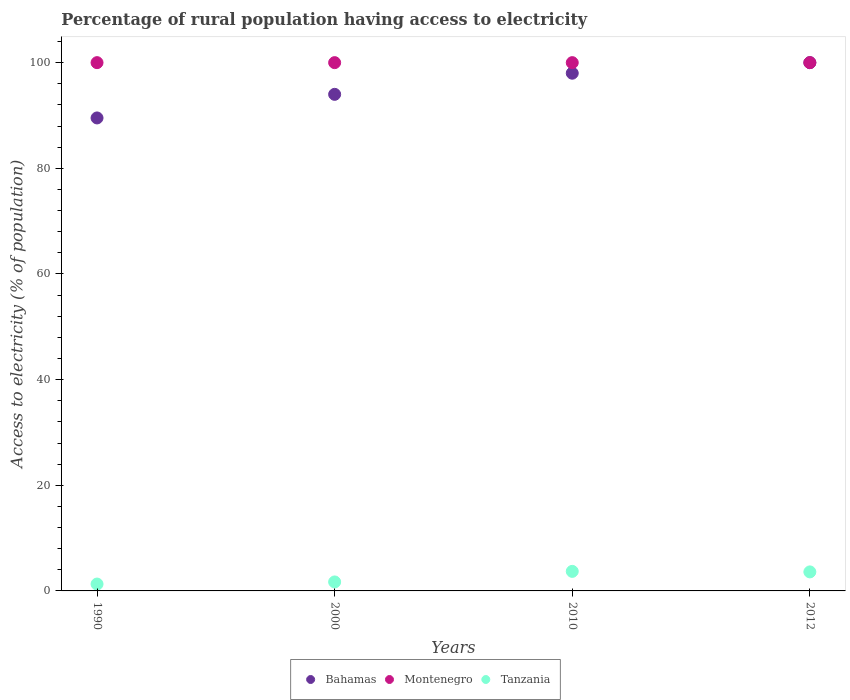How many different coloured dotlines are there?
Provide a short and direct response. 3. What is the percentage of rural population having access to electricity in Bahamas in 2000?
Your answer should be very brief. 94. Across all years, what is the minimum percentage of rural population having access to electricity in Montenegro?
Provide a short and direct response. 100. In which year was the percentage of rural population having access to electricity in Bahamas maximum?
Give a very brief answer. 2012. In which year was the percentage of rural population having access to electricity in Tanzania minimum?
Offer a terse response. 1990. What is the total percentage of rural population having access to electricity in Bahamas in the graph?
Provide a short and direct response. 381.53. What is the difference between the percentage of rural population having access to electricity in Montenegro in 1990 and the percentage of rural population having access to electricity in Tanzania in 2010?
Keep it short and to the point. 96.3. What is the average percentage of rural population having access to electricity in Montenegro per year?
Offer a very short reply. 100. In the year 2012, what is the difference between the percentage of rural population having access to electricity in Tanzania and percentage of rural population having access to electricity in Bahamas?
Your answer should be compact. -96.4. What is the ratio of the percentage of rural population having access to electricity in Montenegro in 1990 to that in 2010?
Make the answer very short. 1. Is the difference between the percentage of rural population having access to electricity in Tanzania in 1990 and 2010 greater than the difference between the percentage of rural population having access to electricity in Bahamas in 1990 and 2010?
Your response must be concise. Yes. What is the difference between the highest and the lowest percentage of rural population having access to electricity in Tanzania?
Provide a short and direct response. 2.4. In how many years, is the percentage of rural population having access to electricity in Bahamas greater than the average percentage of rural population having access to electricity in Bahamas taken over all years?
Keep it short and to the point. 2. Does the percentage of rural population having access to electricity in Montenegro monotonically increase over the years?
Make the answer very short. No. Is the percentage of rural population having access to electricity in Montenegro strictly less than the percentage of rural population having access to electricity in Tanzania over the years?
Offer a very short reply. No. How many dotlines are there?
Your response must be concise. 3. How many years are there in the graph?
Your answer should be very brief. 4. What is the difference between two consecutive major ticks on the Y-axis?
Keep it short and to the point. 20. Are the values on the major ticks of Y-axis written in scientific E-notation?
Your answer should be compact. No. Where does the legend appear in the graph?
Give a very brief answer. Bottom center. What is the title of the graph?
Provide a short and direct response. Percentage of rural population having access to electricity. What is the label or title of the X-axis?
Offer a terse response. Years. What is the label or title of the Y-axis?
Keep it short and to the point. Access to electricity (% of population). What is the Access to electricity (% of population) of Bahamas in 1990?
Offer a terse response. 89.53. What is the Access to electricity (% of population) of Montenegro in 1990?
Offer a terse response. 100. What is the Access to electricity (% of population) in Bahamas in 2000?
Offer a terse response. 94. What is the Access to electricity (% of population) in Montenegro in 2000?
Provide a succinct answer. 100. What is the Access to electricity (% of population) in Bahamas in 2010?
Give a very brief answer. 98. What is the Access to electricity (% of population) in Montenegro in 2010?
Provide a succinct answer. 100. What is the Access to electricity (% of population) in Bahamas in 2012?
Offer a terse response. 100. What is the Access to electricity (% of population) of Montenegro in 2012?
Keep it short and to the point. 100. Across all years, what is the maximum Access to electricity (% of population) of Bahamas?
Your answer should be compact. 100. Across all years, what is the maximum Access to electricity (% of population) in Tanzania?
Ensure brevity in your answer.  3.7. Across all years, what is the minimum Access to electricity (% of population) of Bahamas?
Your answer should be compact. 89.53. Across all years, what is the minimum Access to electricity (% of population) of Tanzania?
Ensure brevity in your answer.  1.3. What is the total Access to electricity (% of population) of Bahamas in the graph?
Keep it short and to the point. 381.53. What is the total Access to electricity (% of population) of Montenegro in the graph?
Make the answer very short. 400. What is the total Access to electricity (% of population) of Tanzania in the graph?
Offer a terse response. 10.3. What is the difference between the Access to electricity (% of population) of Bahamas in 1990 and that in 2000?
Offer a terse response. -4.47. What is the difference between the Access to electricity (% of population) of Montenegro in 1990 and that in 2000?
Your answer should be very brief. 0. What is the difference between the Access to electricity (% of population) in Bahamas in 1990 and that in 2010?
Make the answer very short. -8.47. What is the difference between the Access to electricity (% of population) in Montenegro in 1990 and that in 2010?
Give a very brief answer. 0. What is the difference between the Access to electricity (% of population) of Tanzania in 1990 and that in 2010?
Make the answer very short. -2.4. What is the difference between the Access to electricity (% of population) of Bahamas in 1990 and that in 2012?
Your response must be concise. -10.47. What is the difference between the Access to electricity (% of population) of Tanzania in 1990 and that in 2012?
Make the answer very short. -2.3. What is the difference between the Access to electricity (% of population) of Bahamas in 2000 and that in 2010?
Your answer should be very brief. -4. What is the difference between the Access to electricity (% of population) of Montenegro in 2000 and that in 2010?
Your response must be concise. 0. What is the difference between the Access to electricity (% of population) in Bahamas in 2000 and that in 2012?
Your answer should be compact. -6. What is the difference between the Access to electricity (% of population) of Bahamas in 2010 and that in 2012?
Keep it short and to the point. -2. What is the difference between the Access to electricity (% of population) in Bahamas in 1990 and the Access to electricity (% of population) in Montenegro in 2000?
Provide a succinct answer. -10.47. What is the difference between the Access to electricity (% of population) in Bahamas in 1990 and the Access to electricity (% of population) in Tanzania in 2000?
Give a very brief answer. 87.83. What is the difference between the Access to electricity (% of population) of Montenegro in 1990 and the Access to electricity (% of population) of Tanzania in 2000?
Provide a succinct answer. 98.3. What is the difference between the Access to electricity (% of population) in Bahamas in 1990 and the Access to electricity (% of population) in Montenegro in 2010?
Provide a succinct answer. -10.47. What is the difference between the Access to electricity (% of population) of Bahamas in 1990 and the Access to electricity (% of population) of Tanzania in 2010?
Offer a terse response. 85.83. What is the difference between the Access to electricity (% of population) in Montenegro in 1990 and the Access to electricity (% of population) in Tanzania in 2010?
Provide a succinct answer. 96.3. What is the difference between the Access to electricity (% of population) in Bahamas in 1990 and the Access to electricity (% of population) in Montenegro in 2012?
Make the answer very short. -10.47. What is the difference between the Access to electricity (% of population) of Bahamas in 1990 and the Access to electricity (% of population) of Tanzania in 2012?
Offer a very short reply. 85.93. What is the difference between the Access to electricity (% of population) in Montenegro in 1990 and the Access to electricity (% of population) in Tanzania in 2012?
Your response must be concise. 96.4. What is the difference between the Access to electricity (% of population) of Bahamas in 2000 and the Access to electricity (% of population) of Tanzania in 2010?
Give a very brief answer. 90.3. What is the difference between the Access to electricity (% of population) of Montenegro in 2000 and the Access to electricity (% of population) of Tanzania in 2010?
Offer a terse response. 96.3. What is the difference between the Access to electricity (% of population) of Bahamas in 2000 and the Access to electricity (% of population) of Montenegro in 2012?
Offer a terse response. -6. What is the difference between the Access to electricity (% of population) of Bahamas in 2000 and the Access to electricity (% of population) of Tanzania in 2012?
Provide a short and direct response. 90.4. What is the difference between the Access to electricity (% of population) in Montenegro in 2000 and the Access to electricity (% of population) in Tanzania in 2012?
Your answer should be compact. 96.4. What is the difference between the Access to electricity (% of population) in Bahamas in 2010 and the Access to electricity (% of population) in Tanzania in 2012?
Make the answer very short. 94.4. What is the difference between the Access to electricity (% of population) of Montenegro in 2010 and the Access to electricity (% of population) of Tanzania in 2012?
Offer a very short reply. 96.4. What is the average Access to electricity (% of population) of Bahamas per year?
Ensure brevity in your answer.  95.38. What is the average Access to electricity (% of population) of Tanzania per year?
Make the answer very short. 2.58. In the year 1990, what is the difference between the Access to electricity (% of population) in Bahamas and Access to electricity (% of population) in Montenegro?
Ensure brevity in your answer.  -10.47. In the year 1990, what is the difference between the Access to electricity (% of population) in Bahamas and Access to electricity (% of population) in Tanzania?
Your response must be concise. 88.23. In the year 1990, what is the difference between the Access to electricity (% of population) of Montenegro and Access to electricity (% of population) of Tanzania?
Keep it short and to the point. 98.7. In the year 2000, what is the difference between the Access to electricity (% of population) of Bahamas and Access to electricity (% of population) of Tanzania?
Offer a very short reply. 92.3. In the year 2000, what is the difference between the Access to electricity (% of population) of Montenegro and Access to electricity (% of population) of Tanzania?
Make the answer very short. 98.3. In the year 2010, what is the difference between the Access to electricity (% of population) in Bahamas and Access to electricity (% of population) in Tanzania?
Offer a terse response. 94.3. In the year 2010, what is the difference between the Access to electricity (% of population) in Montenegro and Access to electricity (% of population) in Tanzania?
Keep it short and to the point. 96.3. In the year 2012, what is the difference between the Access to electricity (% of population) of Bahamas and Access to electricity (% of population) of Montenegro?
Provide a succinct answer. 0. In the year 2012, what is the difference between the Access to electricity (% of population) in Bahamas and Access to electricity (% of population) in Tanzania?
Ensure brevity in your answer.  96.4. In the year 2012, what is the difference between the Access to electricity (% of population) in Montenegro and Access to electricity (% of population) in Tanzania?
Offer a terse response. 96.4. What is the ratio of the Access to electricity (% of population) of Bahamas in 1990 to that in 2000?
Your answer should be very brief. 0.95. What is the ratio of the Access to electricity (% of population) in Montenegro in 1990 to that in 2000?
Your response must be concise. 1. What is the ratio of the Access to electricity (% of population) in Tanzania in 1990 to that in 2000?
Provide a succinct answer. 0.76. What is the ratio of the Access to electricity (% of population) in Bahamas in 1990 to that in 2010?
Provide a succinct answer. 0.91. What is the ratio of the Access to electricity (% of population) in Tanzania in 1990 to that in 2010?
Provide a succinct answer. 0.35. What is the ratio of the Access to electricity (% of population) in Bahamas in 1990 to that in 2012?
Make the answer very short. 0.9. What is the ratio of the Access to electricity (% of population) in Tanzania in 1990 to that in 2012?
Your response must be concise. 0.36. What is the ratio of the Access to electricity (% of population) of Bahamas in 2000 to that in 2010?
Provide a short and direct response. 0.96. What is the ratio of the Access to electricity (% of population) of Montenegro in 2000 to that in 2010?
Offer a terse response. 1. What is the ratio of the Access to electricity (% of population) in Tanzania in 2000 to that in 2010?
Provide a succinct answer. 0.46. What is the ratio of the Access to electricity (% of population) of Bahamas in 2000 to that in 2012?
Your response must be concise. 0.94. What is the ratio of the Access to electricity (% of population) in Tanzania in 2000 to that in 2012?
Make the answer very short. 0.47. What is the ratio of the Access to electricity (% of population) in Bahamas in 2010 to that in 2012?
Your answer should be very brief. 0.98. What is the ratio of the Access to electricity (% of population) of Montenegro in 2010 to that in 2012?
Provide a succinct answer. 1. What is the ratio of the Access to electricity (% of population) of Tanzania in 2010 to that in 2012?
Offer a very short reply. 1.03. What is the difference between the highest and the second highest Access to electricity (% of population) in Bahamas?
Offer a terse response. 2. What is the difference between the highest and the lowest Access to electricity (% of population) in Bahamas?
Offer a very short reply. 10.47. What is the difference between the highest and the lowest Access to electricity (% of population) in Montenegro?
Ensure brevity in your answer.  0. What is the difference between the highest and the lowest Access to electricity (% of population) in Tanzania?
Provide a short and direct response. 2.4. 